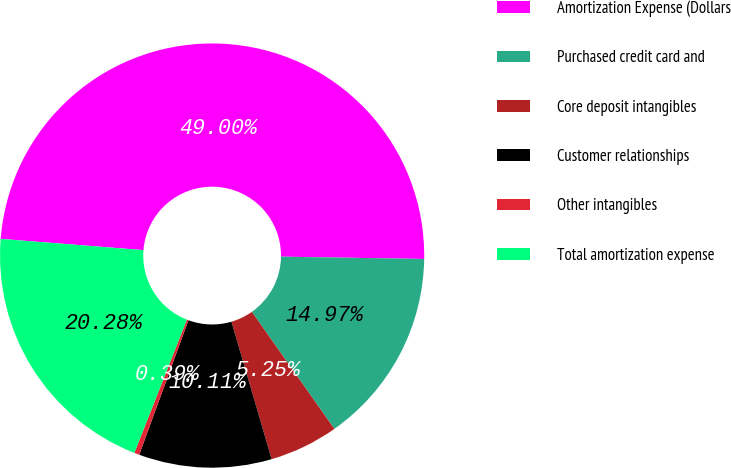Convert chart. <chart><loc_0><loc_0><loc_500><loc_500><pie_chart><fcel>Amortization Expense (Dollars<fcel>Purchased credit card and<fcel>Core deposit intangibles<fcel>Customer relationships<fcel>Other intangibles<fcel>Total amortization expense<nl><fcel>49.0%<fcel>14.97%<fcel>5.25%<fcel>10.11%<fcel>0.39%<fcel>20.28%<nl></chart> 